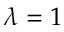Convert formula to latex. <formula><loc_0><loc_0><loc_500><loc_500>\lambda = 1</formula> 